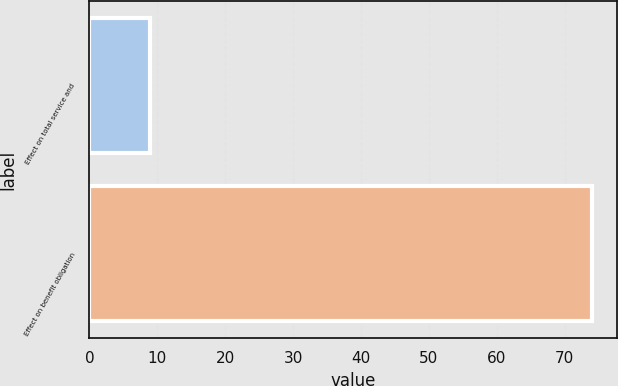Convert chart. <chart><loc_0><loc_0><loc_500><loc_500><bar_chart><fcel>Effect on total service and<fcel>Effect on benefit obligation<nl><fcel>9<fcel>74<nl></chart> 